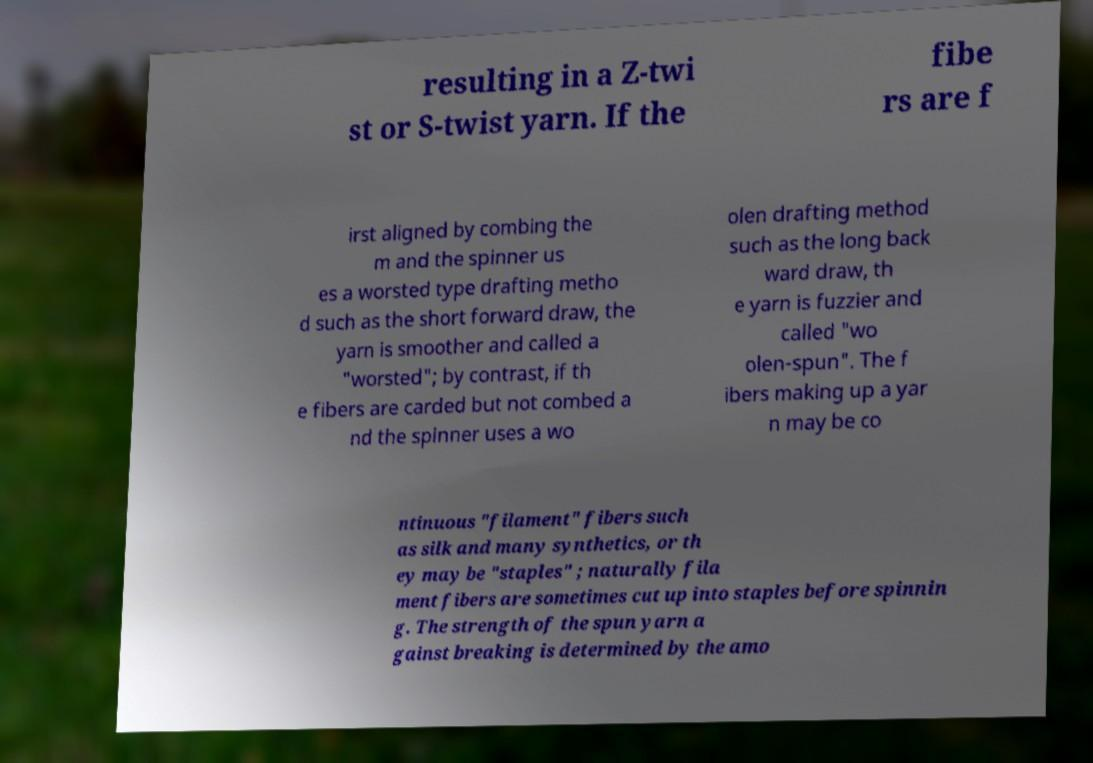There's text embedded in this image that I need extracted. Can you transcribe it verbatim? resulting in a Z-twi st or S-twist yarn. If the fibe rs are f irst aligned by combing the m and the spinner us es a worsted type drafting metho d such as the short forward draw, the yarn is smoother and called a "worsted"; by contrast, if th e fibers are carded but not combed a nd the spinner uses a wo olen drafting method such as the long back ward draw, th e yarn is fuzzier and called "wo olen-spun". The f ibers making up a yar n may be co ntinuous "filament" fibers such as silk and many synthetics, or th ey may be "staples" ; naturally fila ment fibers are sometimes cut up into staples before spinnin g. The strength of the spun yarn a gainst breaking is determined by the amo 